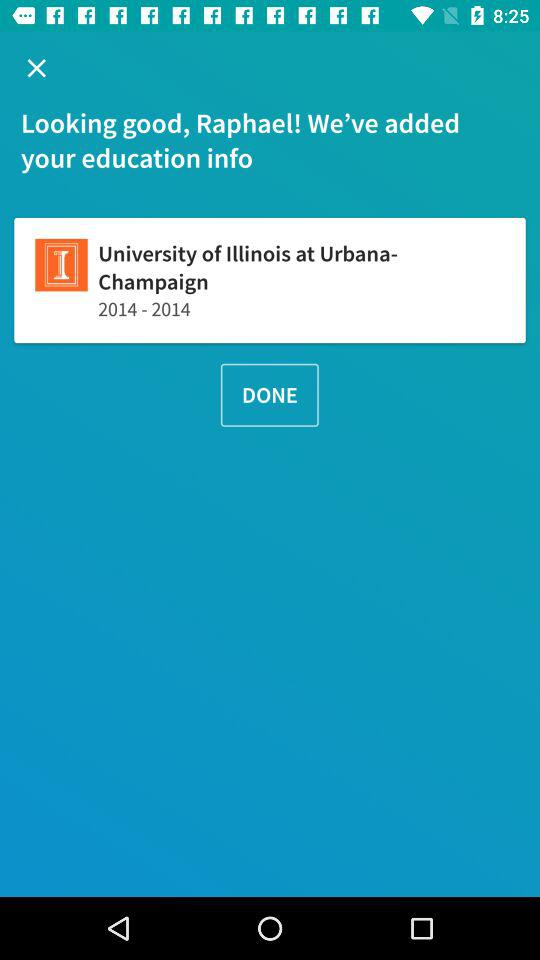How many years did Raphael attend the University of Illinois at Urbana-Champaign?
Answer the question using a single word or phrase. 1 